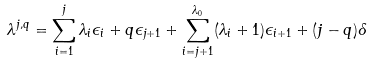Convert formula to latex. <formula><loc_0><loc_0><loc_500><loc_500>\lambda ^ { j , q } = \sum _ { i = 1 } ^ { j } \lambda _ { i } \epsilon _ { i } + q \epsilon _ { j + 1 } + \sum _ { i = j + 1 } ^ { \lambda _ { 0 } } ( \lambda _ { i } + 1 ) \epsilon _ { i + 1 } + ( j - q ) \delta</formula> 